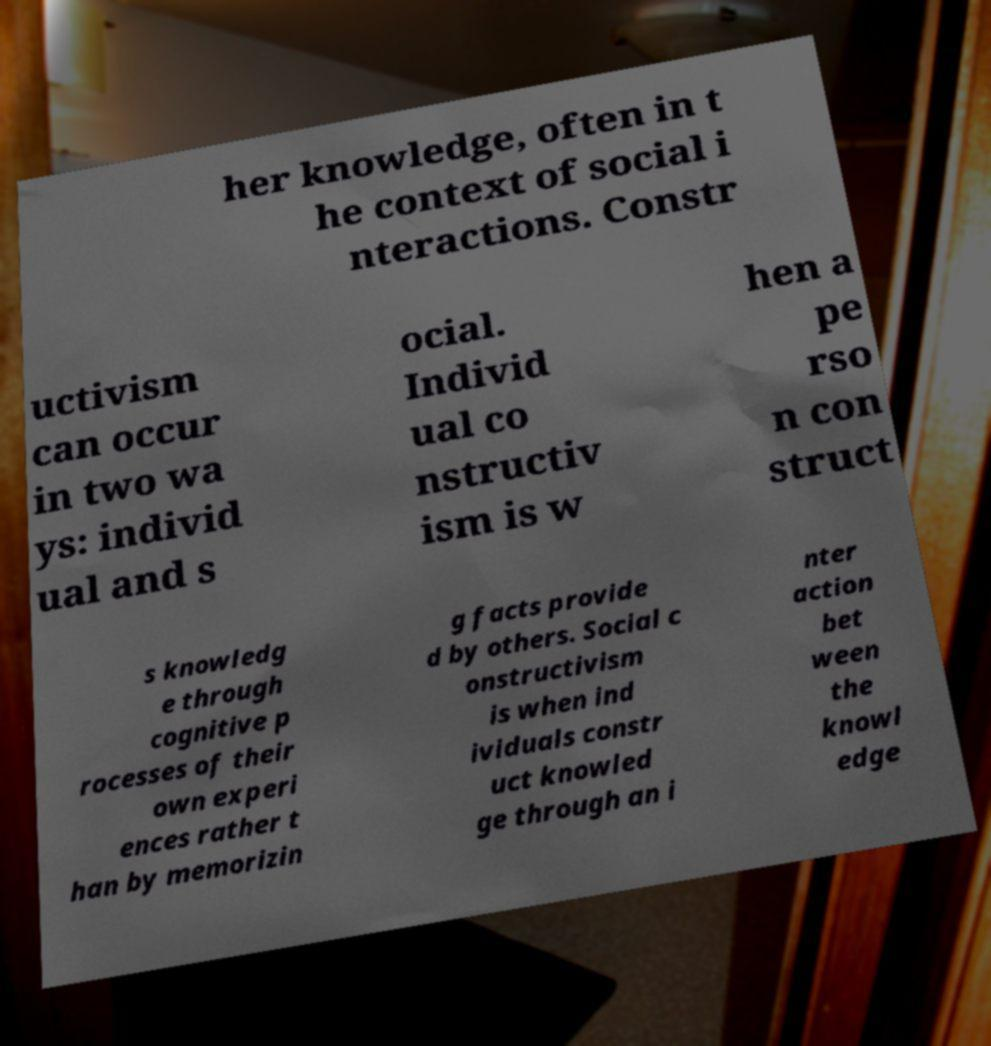I need the written content from this picture converted into text. Can you do that? her knowledge, often in t he context of social i nteractions. Constr uctivism can occur in two wa ys: individ ual and s ocial. Individ ual co nstructiv ism is w hen a pe rso n con struct s knowledg e through cognitive p rocesses of their own experi ences rather t han by memorizin g facts provide d by others. Social c onstructivism is when ind ividuals constr uct knowled ge through an i nter action bet ween the knowl edge 